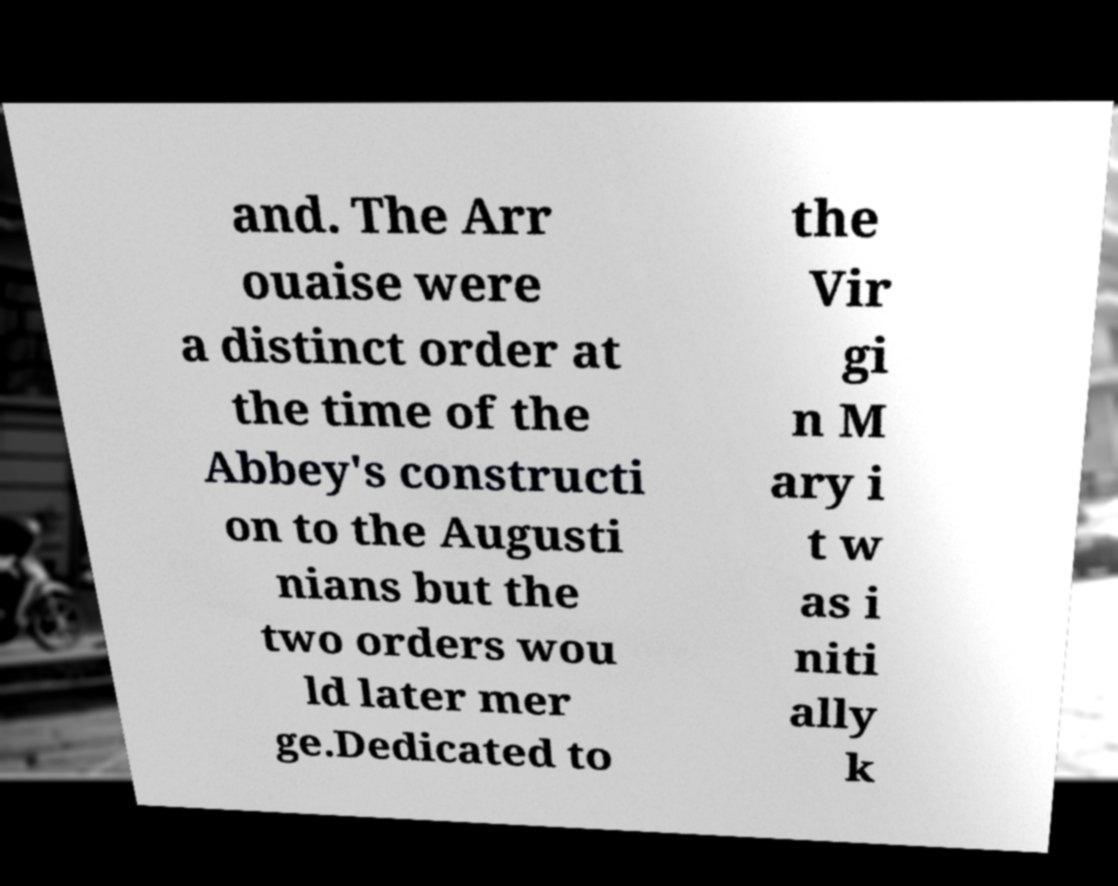For documentation purposes, I need the text within this image transcribed. Could you provide that? and. The Arr ouaise were a distinct order at the time of the Abbey's constructi on to the Augusti nians but the two orders wou ld later mer ge.Dedicated to the Vir gi n M ary i t w as i niti ally k 